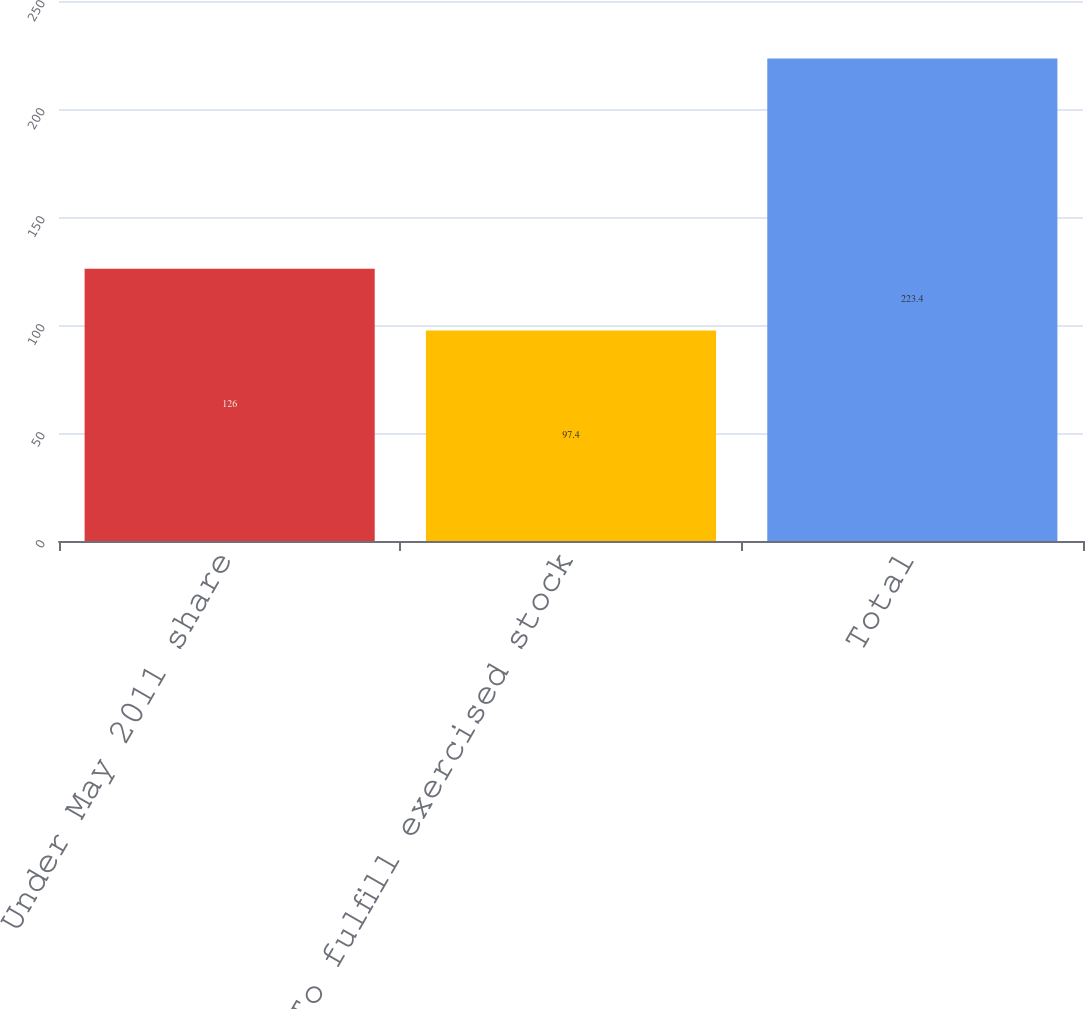<chart> <loc_0><loc_0><loc_500><loc_500><bar_chart><fcel>Under May 2011 share<fcel>To fulfill exercised stock<fcel>Total<nl><fcel>126<fcel>97.4<fcel>223.4<nl></chart> 